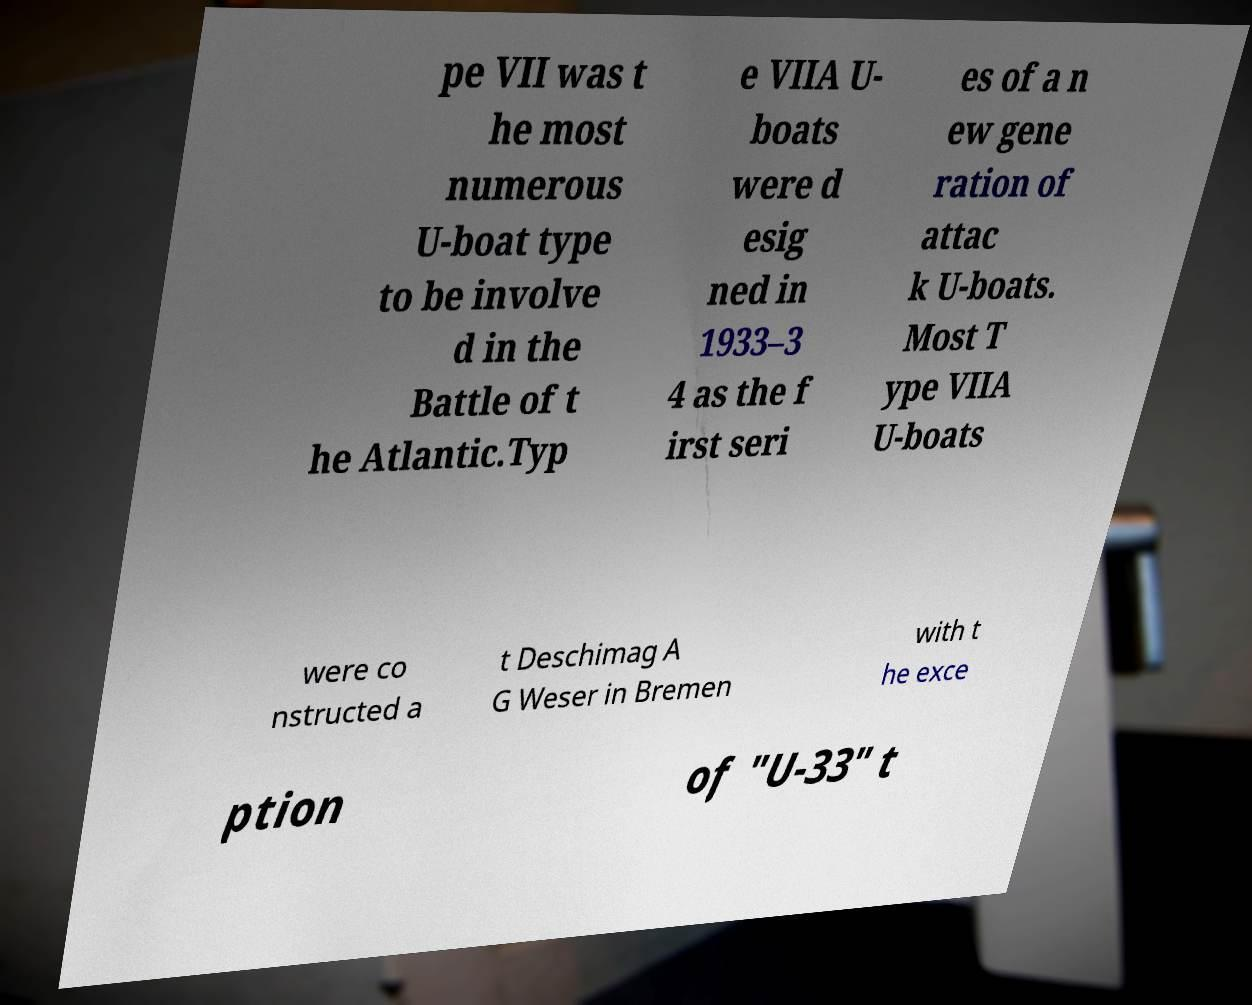Can you read and provide the text displayed in the image?This photo seems to have some interesting text. Can you extract and type it out for me? pe VII was t he most numerous U-boat type to be involve d in the Battle of t he Atlantic.Typ e VIIA U- boats were d esig ned in 1933–3 4 as the f irst seri es of a n ew gene ration of attac k U-boats. Most T ype VIIA U-boats were co nstructed a t Deschimag A G Weser in Bremen with t he exce ption of "U-33" t 